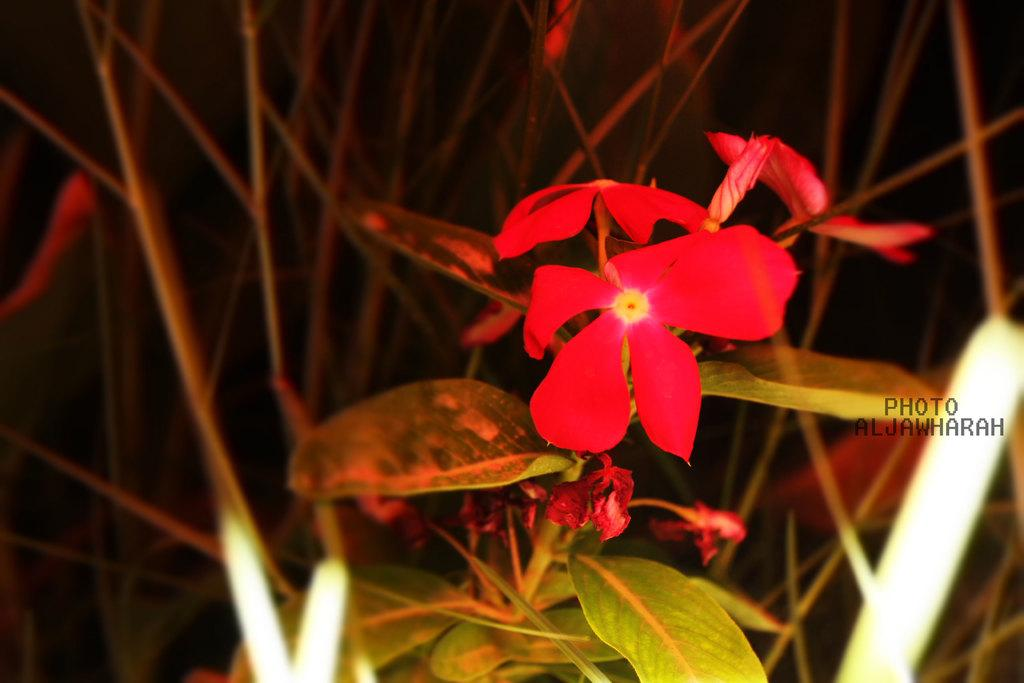What type of living organisms can be seen in the image? There are flowers in the image. What can be seen in the background of the image? There are plants in the background of the image. How many vases are present in the image? There is no vase present in the image. What is the sun's position in the image? The sun is not visible in the image, so its position cannot be determined. 